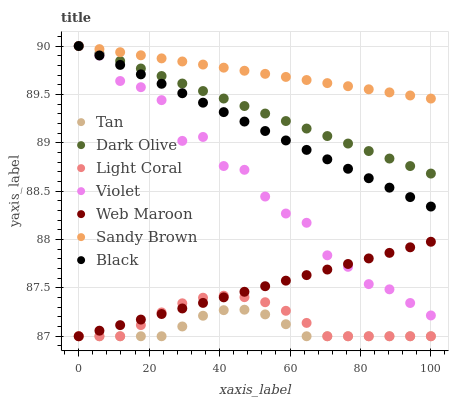Does Tan have the minimum area under the curve?
Answer yes or no. Yes. Does Sandy Brown have the maximum area under the curve?
Answer yes or no. Yes. Does Web Maroon have the minimum area under the curve?
Answer yes or no. No. Does Web Maroon have the maximum area under the curve?
Answer yes or no. No. Is Dark Olive the smoothest?
Answer yes or no. Yes. Is Violet the roughest?
Answer yes or no. Yes. Is Web Maroon the smoothest?
Answer yes or no. No. Is Web Maroon the roughest?
Answer yes or no. No. Does Web Maroon have the lowest value?
Answer yes or no. Yes. Does Black have the lowest value?
Answer yes or no. No. Does Sandy Brown have the highest value?
Answer yes or no. Yes. Does Web Maroon have the highest value?
Answer yes or no. No. Is Tan less than Dark Olive?
Answer yes or no. Yes. Is Violet greater than Light Coral?
Answer yes or no. Yes. Does Web Maroon intersect Tan?
Answer yes or no. Yes. Is Web Maroon less than Tan?
Answer yes or no. No. Is Web Maroon greater than Tan?
Answer yes or no. No. Does Tan intersect Dark Olive?
Answer yes or no. No. 